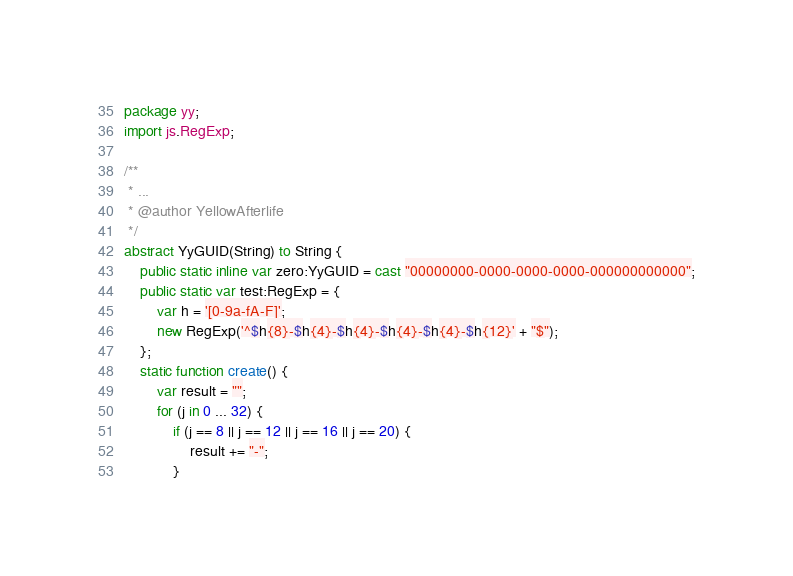Convert code to text. <code><loc_0><loc_0><loc_500><loc_500><_Haxe_>package yy;
import js.RegExp;

/**
 * ...
 * @author YellowAfterlife
 */
abstract YyGUID(String) to String {
	public static inline var zero:YyGUID = cast "00000000-0000-0000-0000-000000000000";
	public static var test:RegExp = {
		var h = '[0-9a-fA-F]';
		new RegExp('^$h{8}-$h{4}-$h{4}-$h{4}-$h{4}-$h{12}' + "$");
	};
	static function create() {
		var result = "";
		for (j in 0 ... 32) {
			if (j == 8 || j == 12 || j == 16 || j == 20) {
				result += "-";
			}</code> 